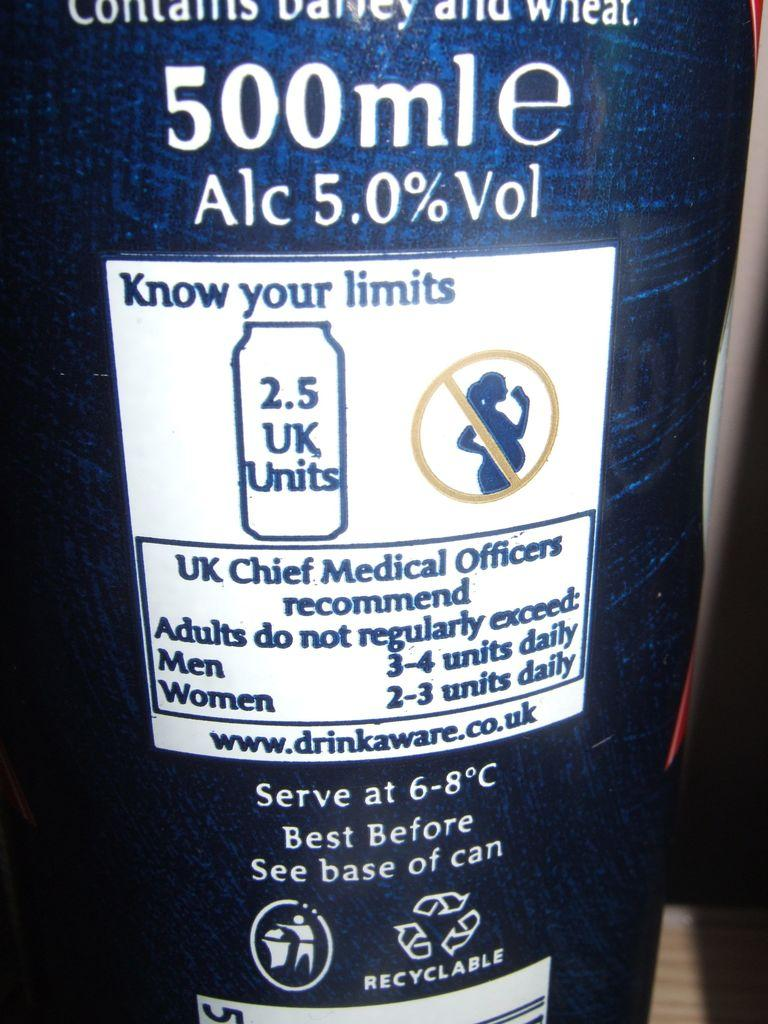<image>
Offer a succinct explanation of the picture presented. A can of alcohol with a warning reminding people of their limits 